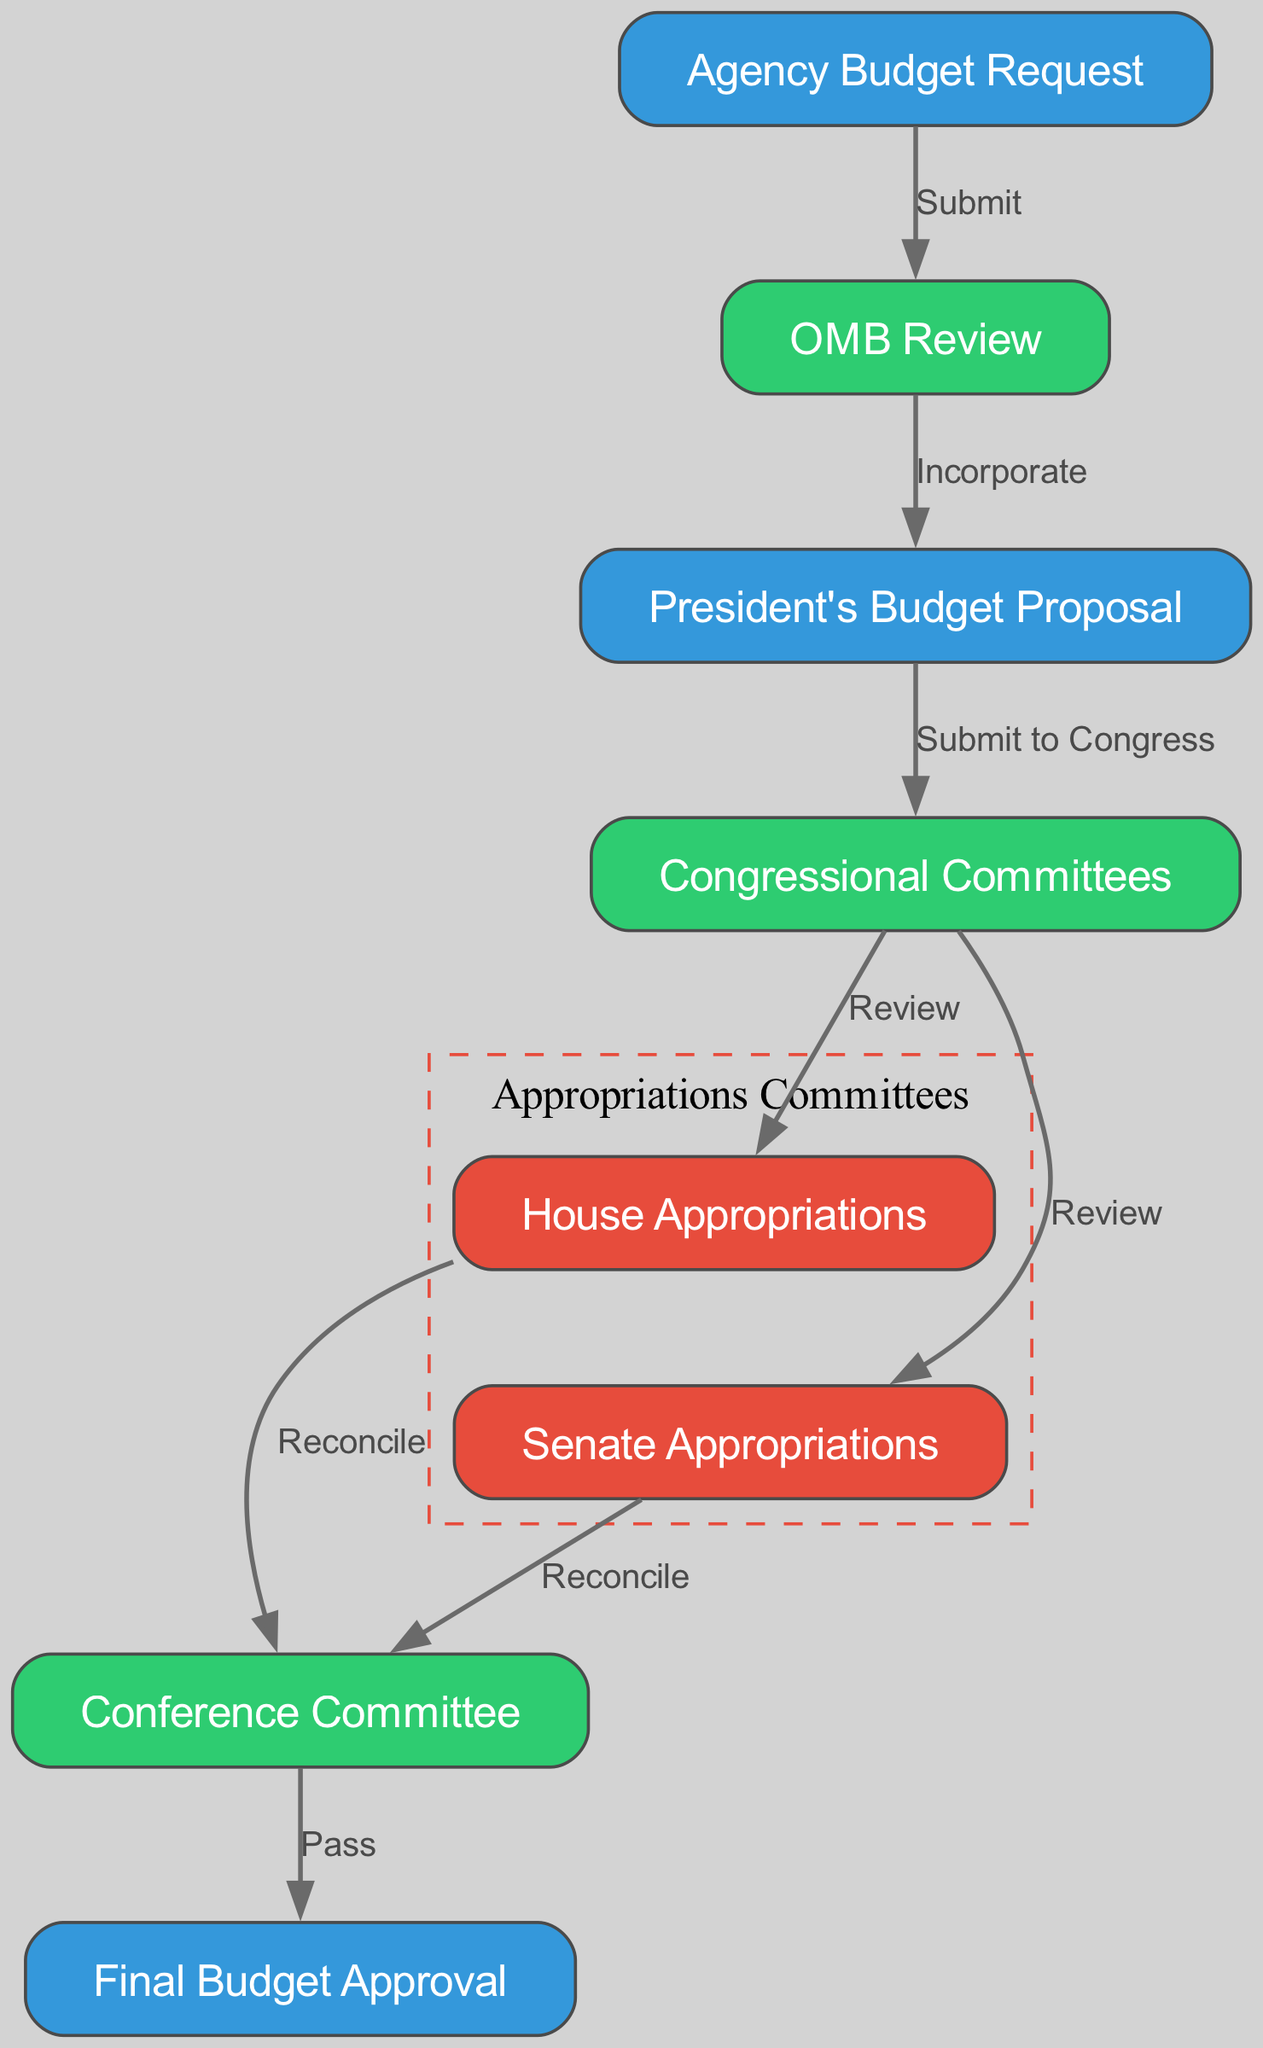What is the first stage in the budget allocation process? The first stage is labeled as "Agency Budget Request" in the diagram. It is the starting point that initiates the budget allocation process.
Answer: Agency Budget Request How many main stages are there in the budget approval process? By counting the distinct nodes in the diagram, we identify a total of eight main stages involved in the budget approval process.
Answer: Eight Which node follows "OMB Review"? The diagram shows that "OMB Review" leads to "President's Budget Proposal," indicating that this is the next stage after the review.
Answer: President's Budget Proposal What are the two congressional bodies responsible for reviewing the budget? The diagram indicates that "House Appropriations" and "Senate Appropriations" are the two committees designated to review the budget.
Answer: House Appropriations and Senate Appropriations How are discrepancies between the House and Senate resolved? The diagram illustrates that discrepancies between the "House Appropriations" and "Senate Appropriations" are reconciled during the "Conference Committee" stage, which is specifically designated for this purpose.
Answer: Conference Committee What is the final output of the budget allocation process? The last node in the diagram is "Final Budget Approval," which indicates that this is the ultimate output that concludes the entire budget allocation and approval process.
Answer: Final Budget Approval Which nodes are involved in the reconciliation stage? The diagram shows that both "House Appropriations" and "Senate Appropriations" feed into the "Conference Committee," which serves as the reconciliation stage for resolving budget differences.
Answer: House Appropriations and Senate Appropriations What action occurs between the "Agency Budget Request" and "OMB Review"? The action occurring between these two nodes is labeled "Submit," indicating that the agency submits its budget request for review by the Office of Management and Budget (OMB).
Answer: Submit How do the "House Appropriations" and "Senate Appropriations" relate to "Final Budget Approval"? According to the diagram, both "House Appropriations" and "Senate Appropriations" influence the "Conference Committee," which then leads to "Final Budget Approval," indicating that both committees play critical roles in the final approval stage.
Answer: Conference Committee to Final Budget Approval 